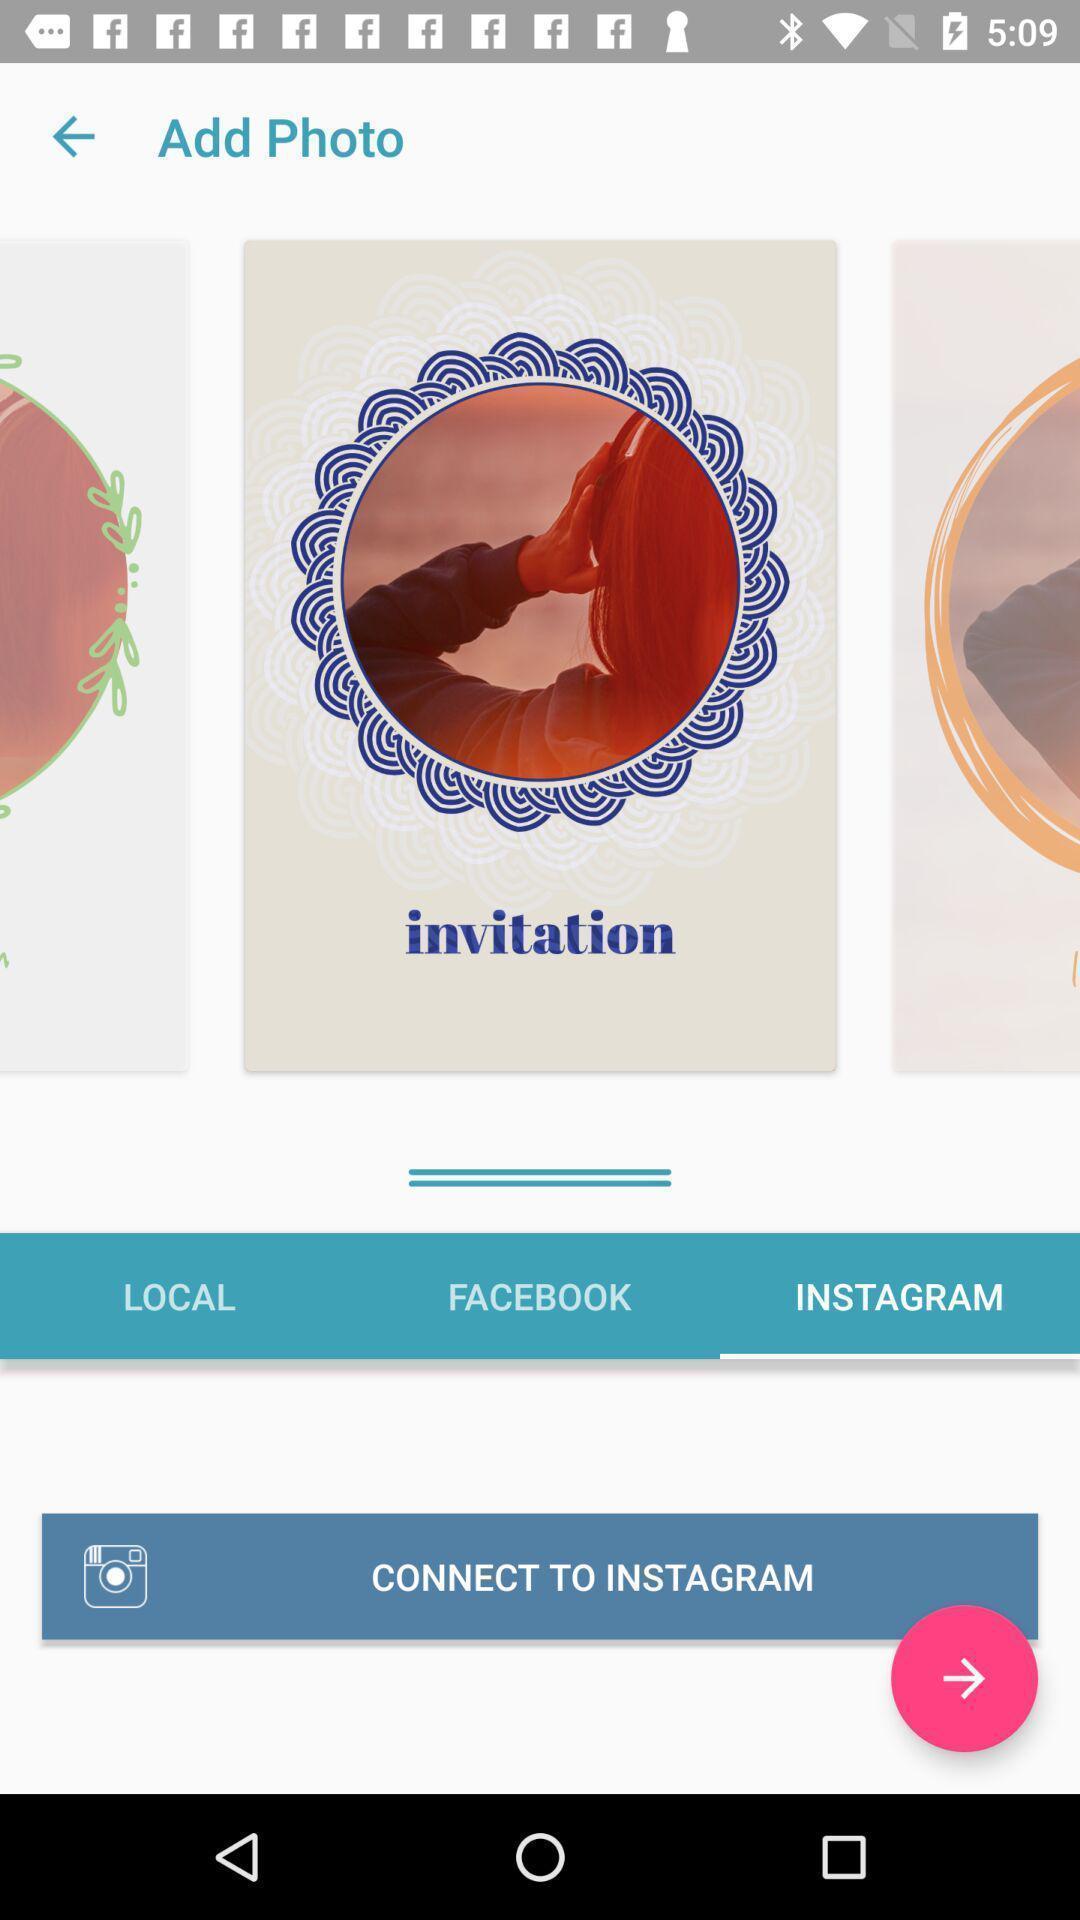Describe this image in words. Page showing to add photo for social media app. 